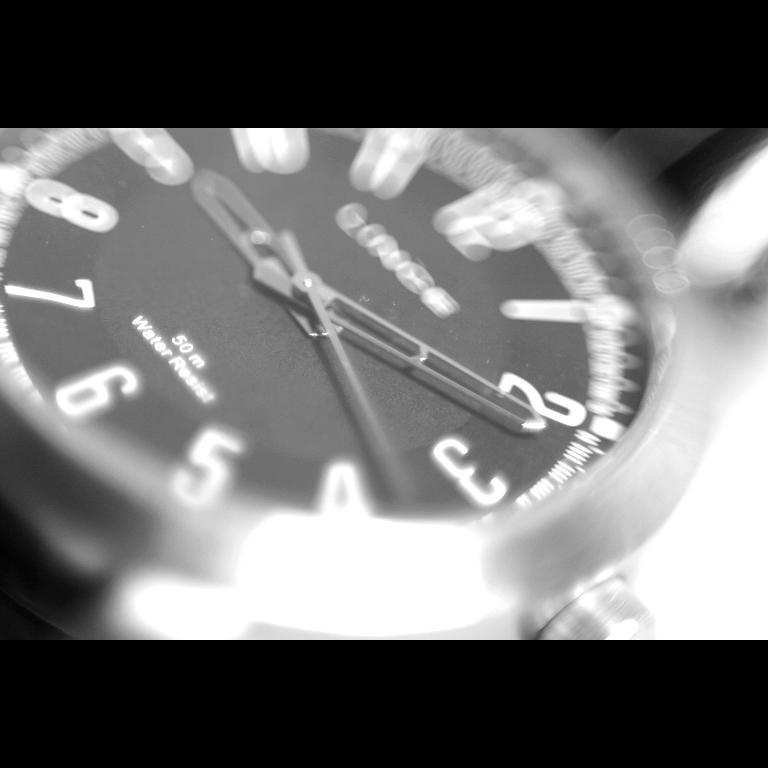<image>
Render a clear and concise summary of the photo. A watch that is water resistant up to 50 meters. 